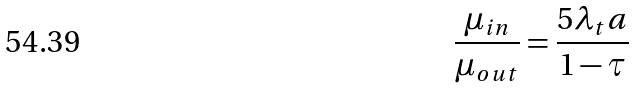<formula> <loc_0><loc_0><loc_500><loc_500>\frac { \mu _ { i n } } { \mu _ { o u t } } = \frac { 5 \lambda _ { t } a } { 1 - \tau }</formula> 